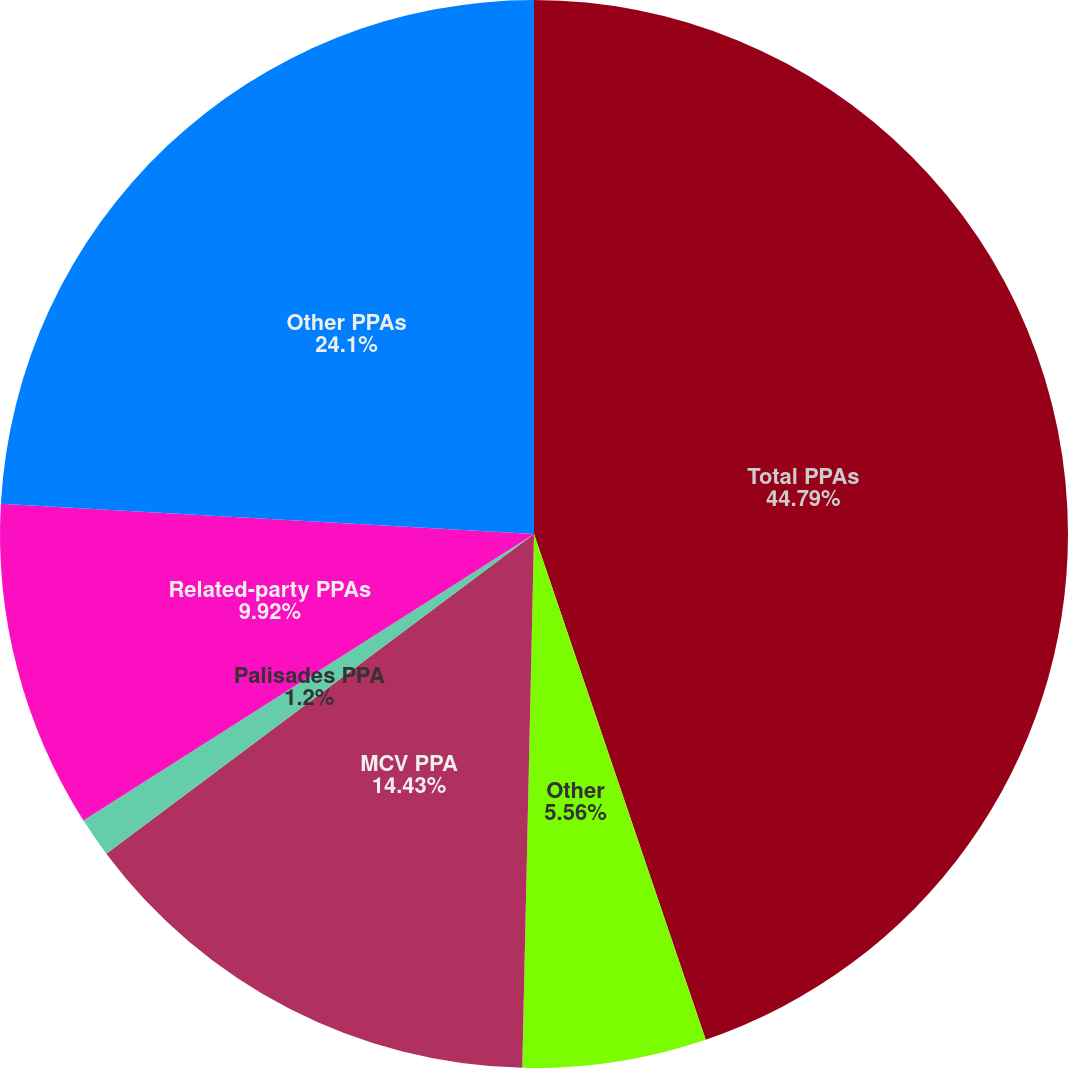Convert chart. <chart><loc_0><loc_0><loc_500><loc_500><pie_chart><fcel>Total PPAs<fcel>Other<fcel>MCV PPA<fcel>Palisades PPA<fcel>Related-party PPAs<fcel>Other PPAs<nl><fcel>44.78%<fcel>5.56%<fcel>14.43%<fcel>1.2%<fcel>9.92%<fcel>24.09%<nl></chart> 